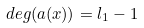Convert formula to latex. <formula><loc_0><loc_0><loc_500><loc_500>d e g ( a ( x ) ) = l _ { 1 } - 1</formula> 